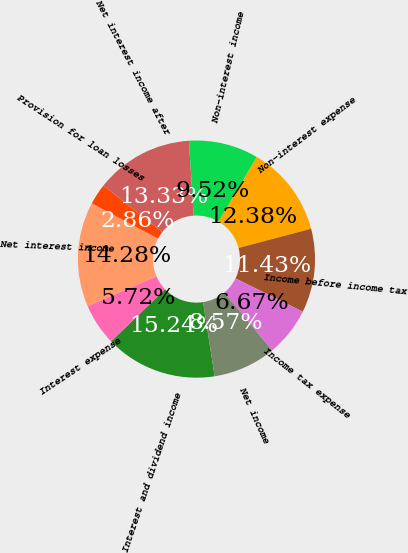Convert chart to OTSL. <chart><loc_0><loc_0><loc_500><loc_500><pie_chart><fcel>Interest and dividend income<fcel>Interest expense<fcel>Net interest income<fcel>Provision for loan losses<fcel>Net interest income after<fcel>Non-interest income<fcel>Non-interest expense<fcel>Income before income tax<fcel>Income tax expense<fcel>Net income<nl><fcel>15.24%<fcel>5.72%<fcel>14.28%<fcel>2.86%<fcel>13.33%<fcel>9.52%<fcel>12.38%<fcel>11.43%<fcel>6.67%<fcel>8.57%<nl></chart> 